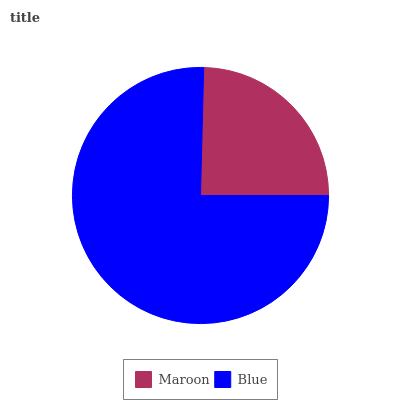Is Maroon the minimum?
Answer yes or no. Yes. Is Blue the maximum?
Answer yes or no. Yes. Is Blue the minimum?
Answer yes or no. No. Is Blue greater than Maroon?
Answer yes or no. Yes. Is Maroon less than Blue?
Answer yes or no. Yes. Is Maroon greater than Blue?
Answer yes or no. No. Is Blue less than Maroon?
Answer yes or no. No. Is Blue the high median?
Answer yes or no. Yes. Is Maroon the low median?
Answer yes or no. Yes. Is Maroon the high median?
Answer yes or no. No. Is Blue the low median?
Answer yes or no. No. 